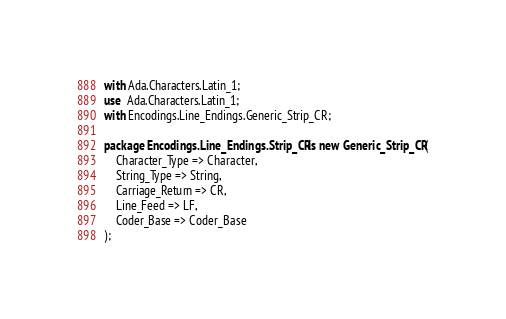Convert code to text. <code><loc_0><loc_0><loc_500><loc_500><_Ada_>with Ada.Characters.Latin_1;
use  Ada.Characters.Latin_1;
with Encodings.Line_Endings.Generic_Strip_CR;

package Encodings.Line_Endings.Strip_CR is new Generic_Strip_CR(
	Character_Type => Character,
	String_Type => String,
	Carriage_Return => CR,
	Line_Feed => LF,
	Coder_Base => Coder_Base
);
</code> 